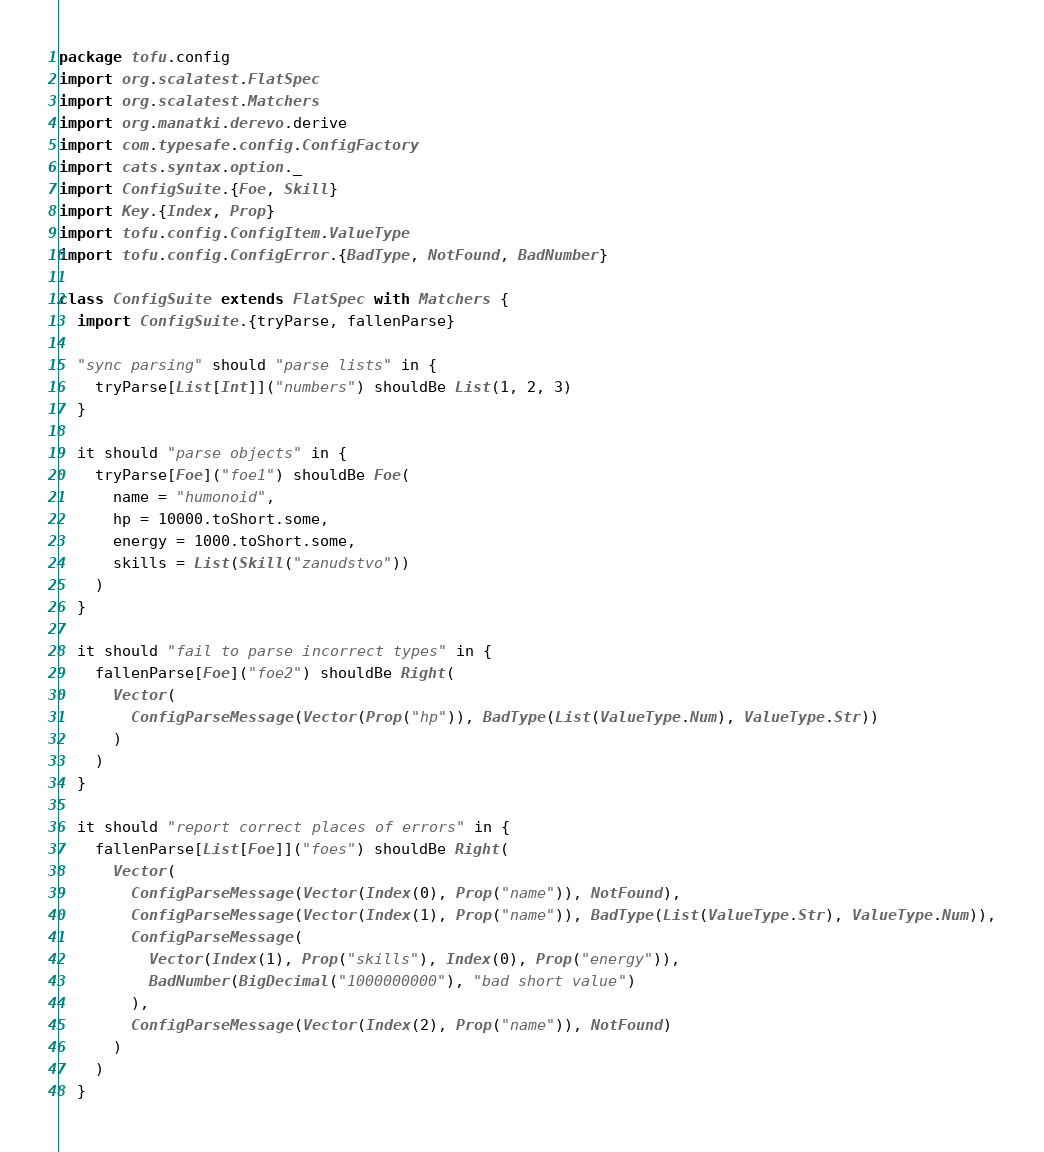<code> <loc_0><loc_0><loc_500><loc_500><_Scala_>package tofu.config
import org.scalatest.FlatSpec
import org.scalatest.Matchers
import org.manatki.derevo.derive
import com.typesafe.config.ConfigFactory
import cats.syntax.option._
import ConfigSuite.{Foe, Skill}
import Key.{Index, Prop}
import tofu.config.ConfigItem.ValueType
import tofu.config.ConfigError.{BadType, NotFound, BadNumber}

class ConfigSuite extends FlatSpec with Matchers {
  import ConfigSuite.{tryParse, fallenParse}

  "sync parsing" should "parse lists" in {
    tryParse[List[Int]]("numbers") shouldBe List(1, 2, 3)
  }

  it should "parse objects" in {
    tryParse[Foe]("foe1") shouldBe Foe(
      name = "humonoid",
      hp = 10000.toShort.some,
      energy = 1000.toShort.some,
      skills = List(Skill("zanudstvo"))
    )
  }

  it should "fail to parse incorrect types" in {
    fallenParse[Foe]("foe2") shouldBe Right(
      Vector(
        ConfigParseMessage(Vector(Prop("hp")), BadType(List(ValueType.Num), ValueType.Str))
      )
    )
  }

  it should "report correct places of errors" in {
    fallenParse[List[Foe]]("foes") shouldBe Right(
      Vector(
        ConfigParseMessage(Vector(Index(0), Prop("name")), NotFound),
        ConfigParseMessage(Vector(Index(1), Prop("name")), BadType(List(ValueType.Str), ValueType.Num)),
        ConfigParseMessage(
          Vector(Index(1), Prop("skills"), Index(0), Prop("energy")),
          BadNumber(BigDecimal("1000000000"), "bad short value")
        ),
        ConfigParseMessage(Vector(Index(2), Prop("name")), NotFound)
      )
    )
  }
</code> 